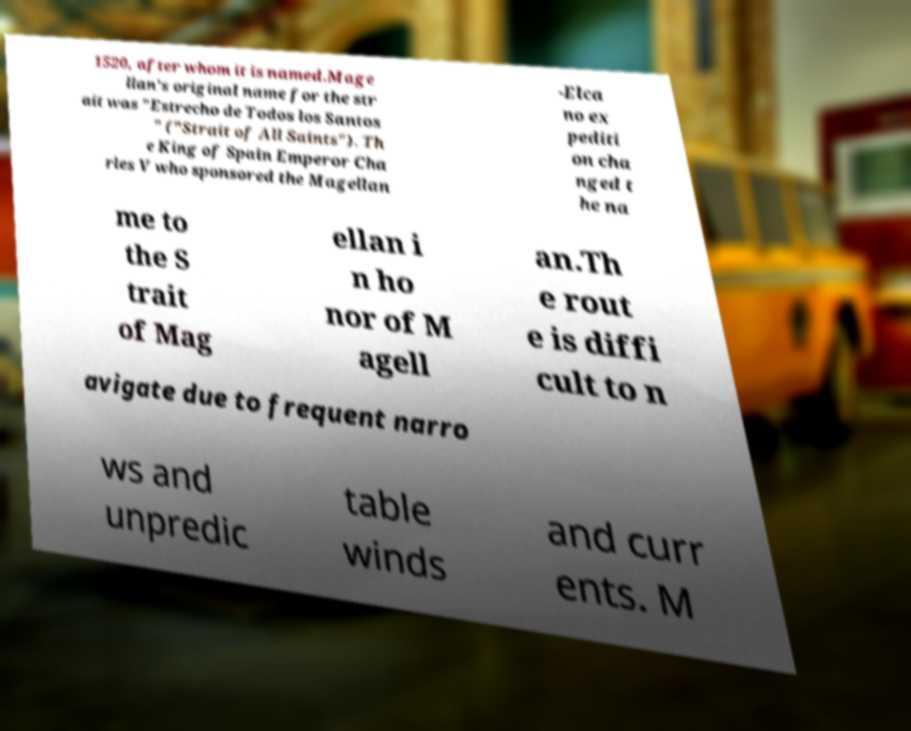For documentation purposes, I need the text within this image transcribed. Could you provide that? 1520, after whom it is named.Mage llan's original name for the str ait was "Estrecho de Todos los Santos " ("Strait of All Saints"). Th e King of Spain Emperor Cha rles V who sponsored the Magellan -Elca no ex pediti on cha nged t he na me to the S trait of Mag ellan i n ho nor of M agell an.Th e rout e is diffi cult to n avigate due to frequent narro ws and unpredic table winds and curr ents. M 